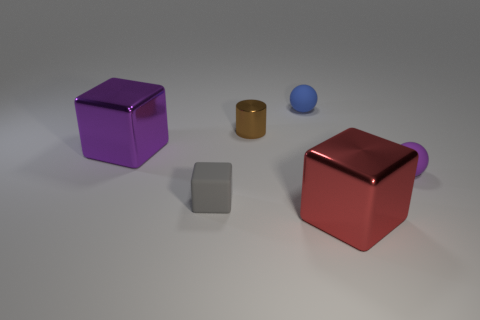Is there a yellow object? Upon reviewing the image, it appears there is no yellow object present. The objects in the scene include a purple cube, a red cube with a handle, a metallic cylinder, and a small blue sphere. 